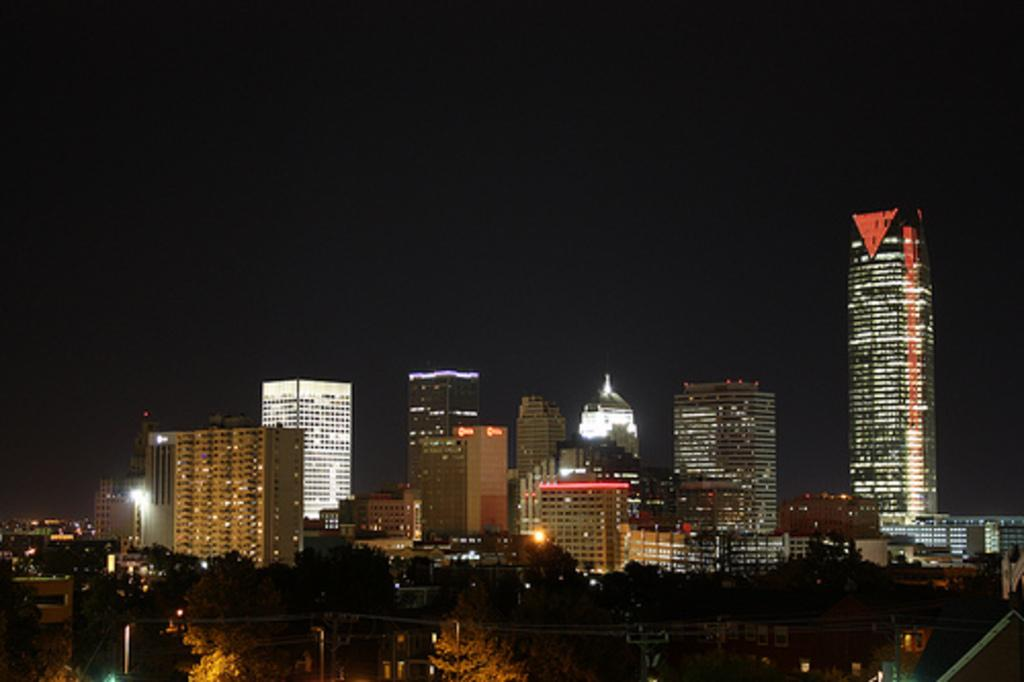What is located in the center of the image? There are buildings in the center of the image. What type of natural elements can be seen in the image? There are trees in the image. What can be seen at the bottom side of the image? There is water visible at the bottom side of the image. How many parcels are floating on the water in the image? There are no parcels present in the image; it features buildings, trees, and water. What word is written on the trees in the image? There are no words written on the trees in the image; it only shows trees, buildings, and water. 